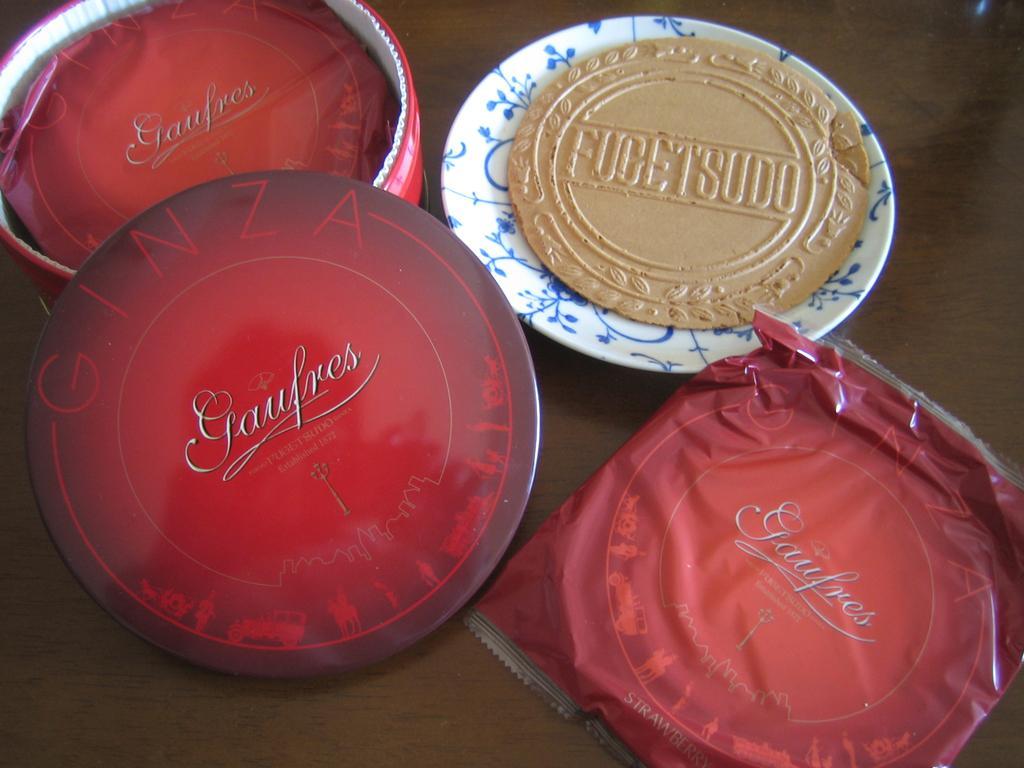In one or two sentences, can you explain what this image depicts? In this picture I can see a plate, red color cover, on the left side it looks like a bowl and a cap. 